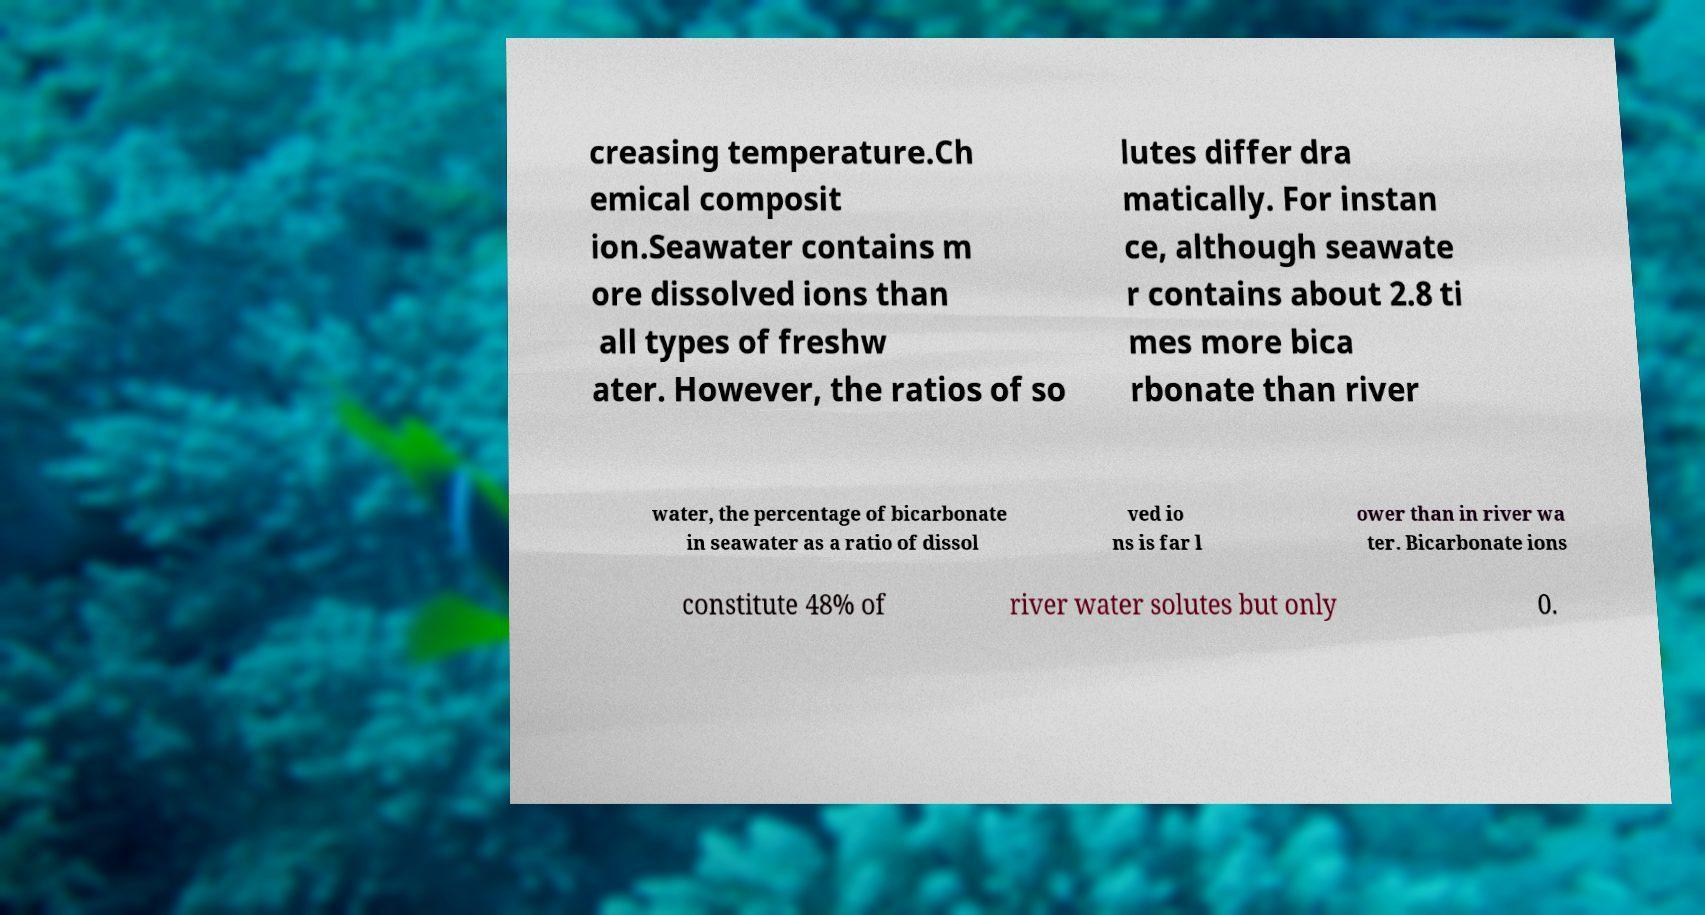Can you accurately transcribe the text from the provided image for me? creasing temperature.Ch emical composit ion.Seawater contains m ore dissolved ions than all types of freshw ater. However, the ratios of so lutes differ dra matically. For instan ce, although seawate r contains about 2.8 ti mes more bica rbonate than river water, the percentage of bicarbonate in seawater as a ratio of dissol ved io ns is far l ower than in river wa ter. Bicarbonate ions constitute 48% of river water solutes but only 0. 